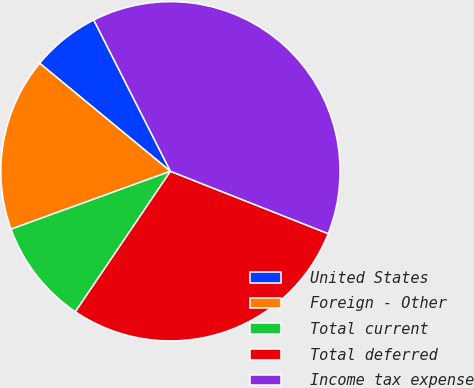Convert chart. <chart><loc_0><loc_0><loc_500><loc_500><pie_chart><fcel>United States<fcel>Foreign - Other<fcel>Total current<fcel>Total deferred<fcel>Income tax expense<nl><fcel>6.55%<fcel>16.53%<fcel>9.99%<fcel>28.48%<fcel>38.46%<nl></chart> 